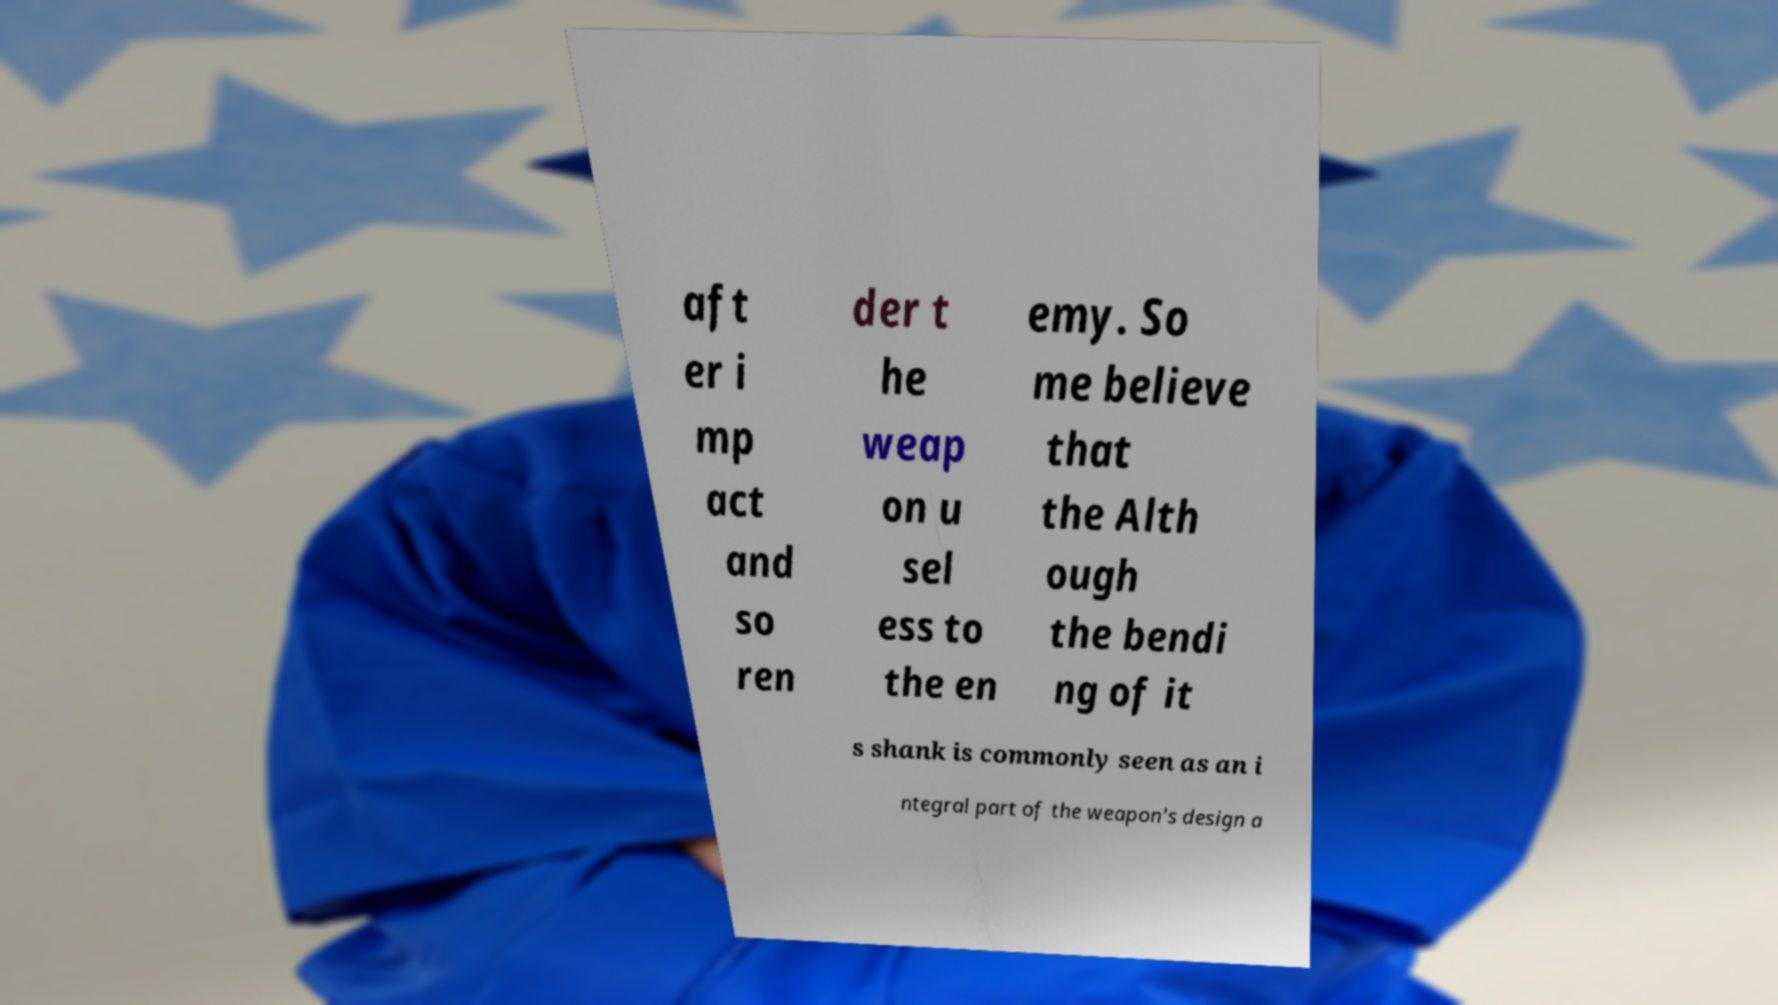Please identify and transcribe the text found in this image. aft er i mp act and so ren der t he weap on u sel ess to the en emy. So me believe that the Alth ough the bendi ng of it s shank is commonly seen as an i ntegral part of the weapon's design a 